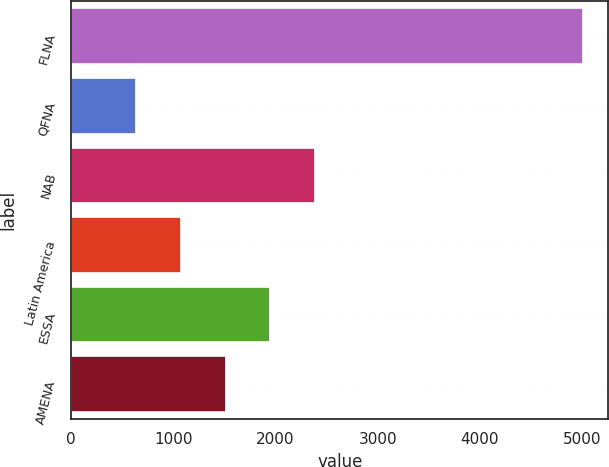Convert chart to OTSL. <chart><loc_0><loc_0><loc_500><loc_500><bar_chart><fcel>FLNA<fcel>QFNA<fcel>NAB<fcel>Latin America<fcel>ESSA<fcel>AMENA<nl><fcel>5008<fcel>637<fcel>2385.4<fcel>1074.1<fcel>1948.3<fcel>1511.2<nl></chart> 